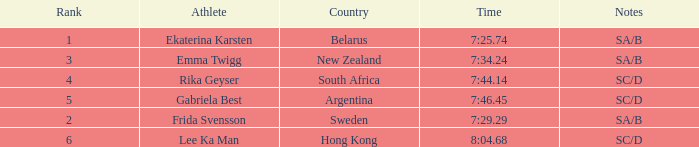What is the race time for emma twigg? 7:34.24. 